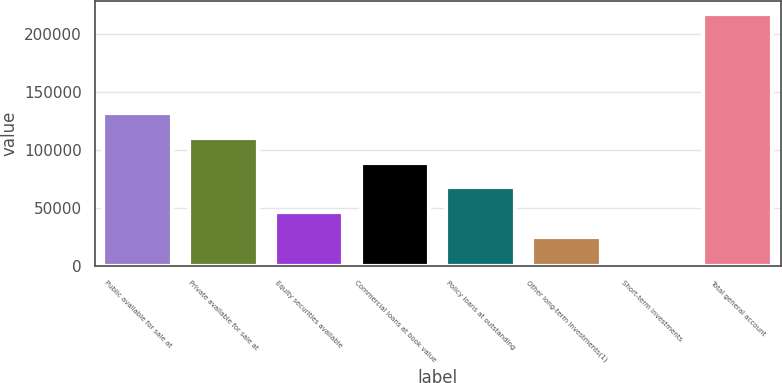Convert chart to OTSL. <chart><loc_0><loc_0><loc_500><loc_500><bar_chart><fcel>Public available for sale at<fcel>Private available for sale at<fcel>Equity securities available<fcel>Commercial loans at book value<fcel>Policy loans at outstanding<fcel>Other long-term investments(1)<fcel>Short-term investments<fcel>Total general account<nl><fcel>131697<fcel>110390<fcel>46465.8<fcel>89081.6<fcel>67773.7<fcel>25157.9<fcel>3850<fcel>216929<nl></chart> 